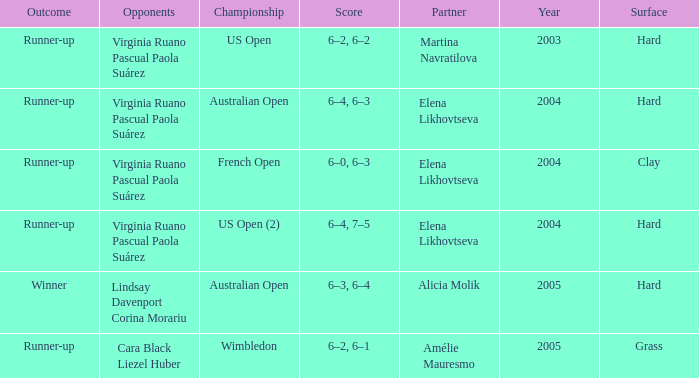When us open (2) is the championship what is the surface? Hard. 